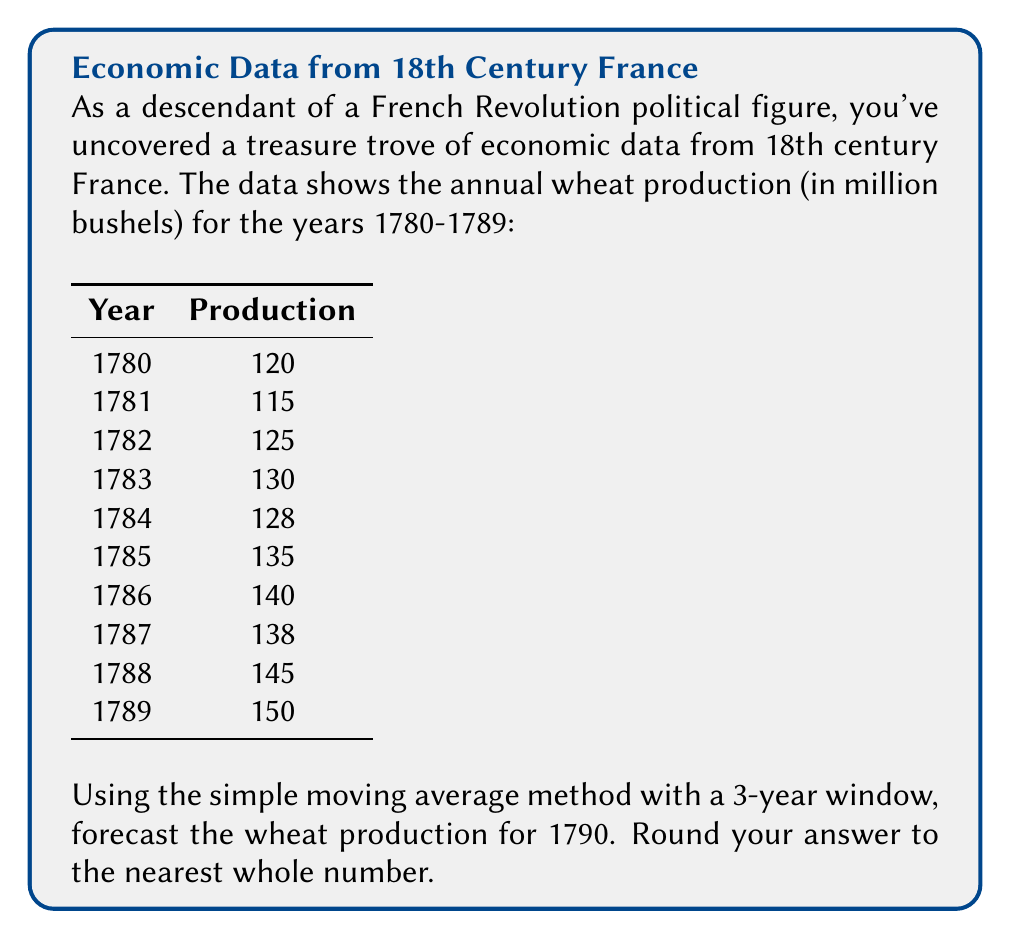Can you solve this math problem? To forecast the wheat production for 1790 using a 3-year simple moving average, we'll follow these steps:

1) The simple moving average formula for a 3-year window is:

   $$SMA_t = \frac{Y_{t-2} + Y_{t-1} + Y_t}{3}$$

   where $Y_t$ is the value at time $t$.

2) We need to calculate the average of the last three years (1787, 1788, 1789):

   $$SMA_{1790} = \frac{Y_{1787} + Y_{1788} + Y_{1789}}{3}$$

3) Substituting the values:

   $$SMA_{1790} = \frac{138 + 145 + 150}{3}$$

4) Calculating:

   $$SMA_{1790} = \frac{433}{3} = 144.3333...$$

5) Rounding to the nearest whole number:

   $$SMA_{1790} \approx 144$$

Therefore, the forecasted wheat production for 1790 is 144 million bushels.
Answer: 144 million bushels 